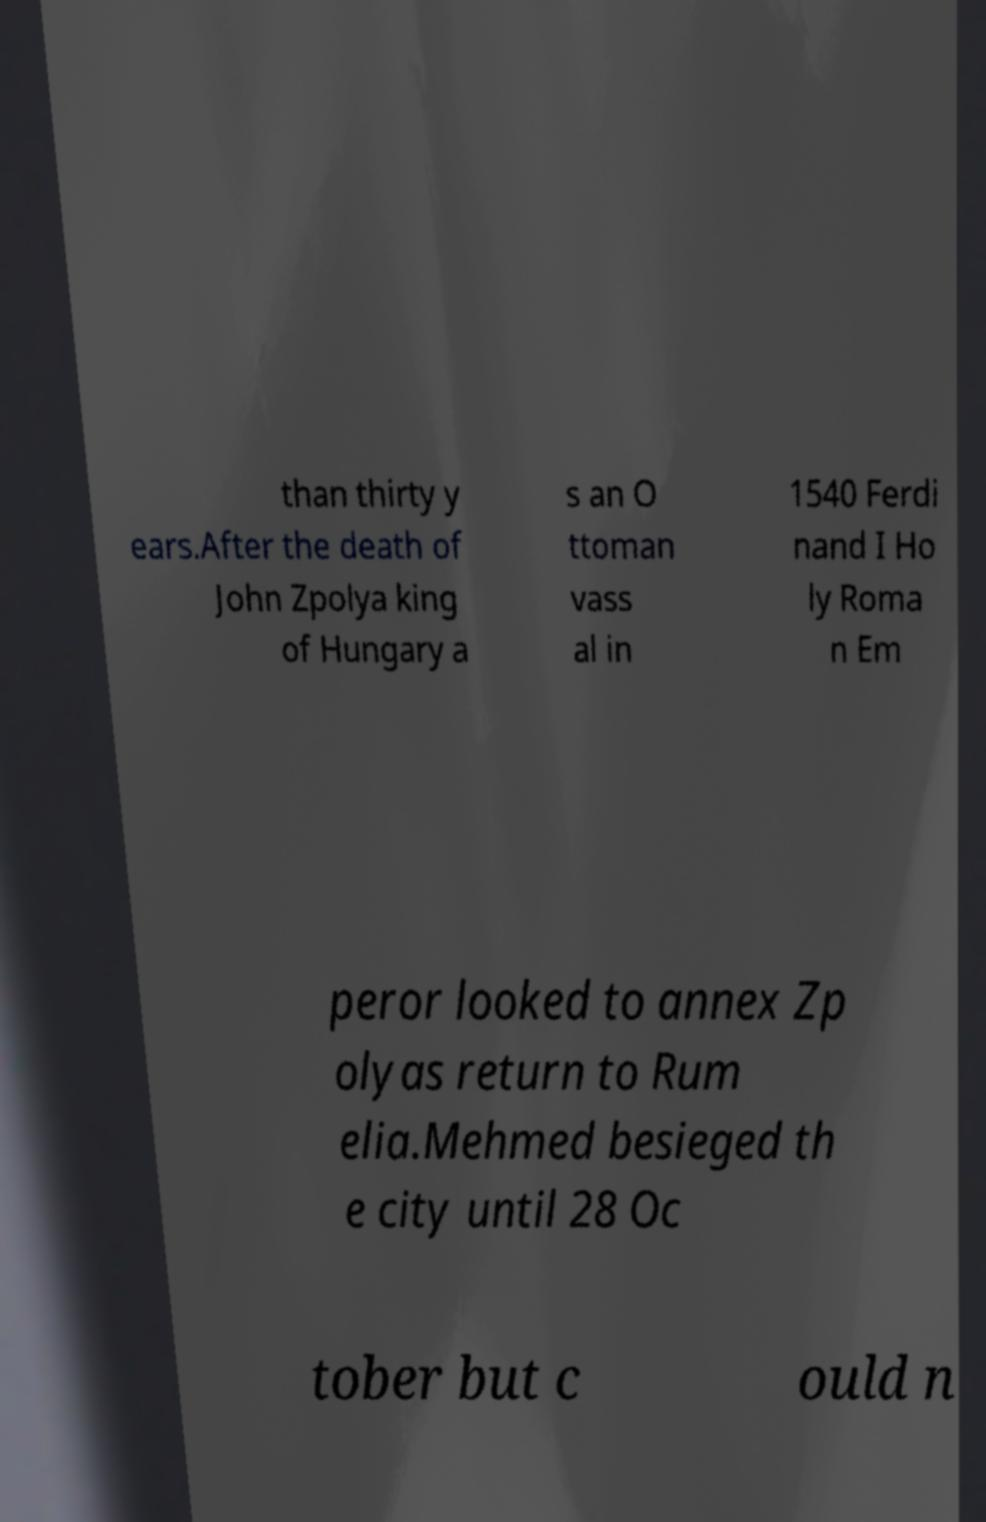What messages or text are displayed in this image? I need them in a readable, typed format. than thirty y ears.After the death of John Zpolya king of Hungary a s an O ttoman vass al in 1540 Ferdi nand I Ho ly Roma n Em peror looked to annex Zp olyas return to Rum elia.Mehmed besieged th e city until 28 Oc tober but c ould n 